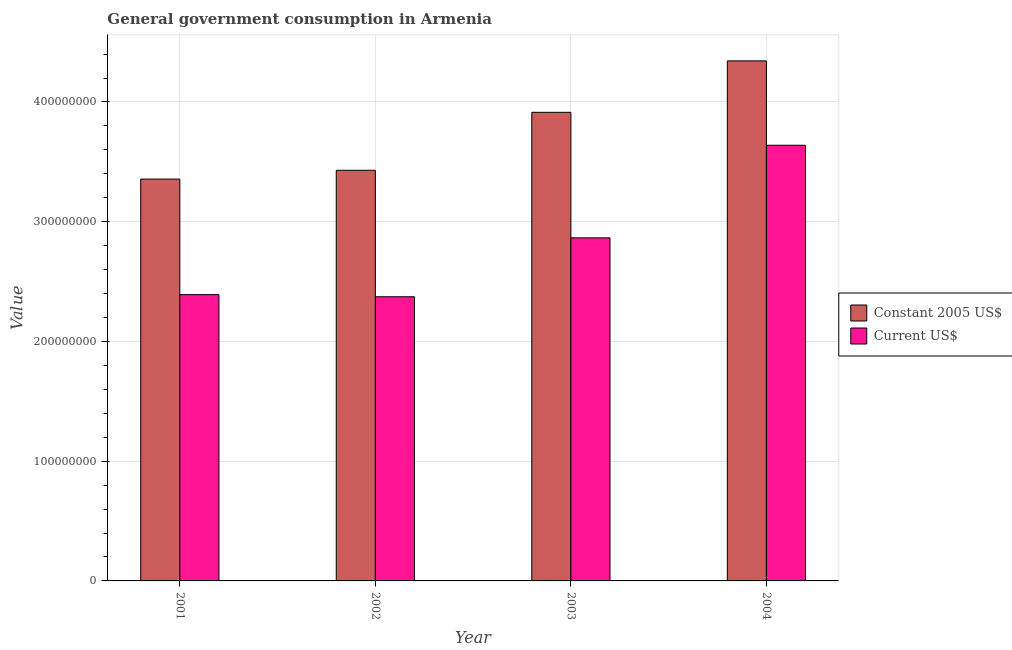How many groups of bars are there?
Give a very brief answer. 4. Are the number of bars per tick equal to the number of legend labels?
Ensure brevity in your answer.  Yes. What is the label of the 4th group of bars from the left?
Your answer should be very brief. 2004. What is the value consumed in current us$ in 2004?
Provide a short and direct response. 3.64e+08. Across all years, what is the maximum value consumed in constant 2005 us$?
Your answer should be compact. 4.34e+08. Across all years, what is the minimum value consumed in constant 2005 us$?
Offer a very short reply. 3.36e+08. In which year was the value consumed in constant 2005 us$ maximum?
Your answer should be compact. 2004. In which year was the value consumed in constant 2005 us$ minimum?
Offer a very short reply. 2001. What is the total value consumed in constant 2005 us$ in the graph?
Ensure brevity in your answer.  1.50e+09. What is the difference between the value consumed in current us$ in 2002 and that in 2004?
Offer a terse response. -1.27e+08. What is the difference between the value consumed in current us$ in 2001 and the value consumed in constant 2005 us$ in 2004?
Provide a short and direct response. -1.25e+08. What is the average value consumed in constant 2005 us$ per year?
Provide a short and direct response. 3.76e+08. In the year 2003, what is the difference between the value consumed in current us$ and value consumed in constant 2005 us$?
Keep it short and to the point. 0. What is the ratio of the value consumed in current us$ in 2001 to that in 2004?
Offer a terse response. 0.66. Is the difference between the value consumed in constant 2005 us$ in 2002 and 2003 greater than the difference between the value consumed in current us$ in 2002 and 2003?
Offer a very short reply. No. What is the difference between the highest and the second highest value consumed in current us$?
Ensure brevity in your answer.  7.73e+07. What is the difference between the highest and the lowest value consumed in current us$?
Provide a succinct answer. 1.27e+08. Is the sum of the value consumed in constant 2005 us$ in 2001 and 2003 greater than the maximum value consumed in current us$ across all years?
Your response must be concise. Yes. What does the 2nd bar from the left in 2004 represents?
Offer a terse response. Current US$. What does the 1st bar from the right in 2002 represents?
Provide a succinct answer. Current US$. How many years are there in the graph?
Your answer should be compact. 4. What is the difference between two consecutive major ticks on the Y-axis?
Give a very brief answer. 1.00e+08. Where does the legend appear in the graph?
Your response must be concise. Center right. How many legend labels are there?
Offer a very short reply. 2. How are the legend labels stacked?
Ensure brevity in your answer.  Vertical. What is the title of the graph?
Your answer should be compact. General government consumption in Armenia. What is the label or title of the X-axis?
Your response must be concise. Year. What is the label or title of the Y-axis?
Provide a succinct answer. Value. What is the Value of Constant 2005 US$ in 2001?
Make the answer very short. 3.36e+08. What is the Value in Current US$ in 2001?
Your response must be concise. 2.39e+08. What is the Value of Constant 2005 US$ in 2002?
Make the answer very short. 3.43e+08. What is the Value in Current US$ in 2002?
Keep it short and to the point. 2.37e+08. What is the Value of Constant 2005 US$ in 2003?
Offer a terse response. 3.91e+08. What is the Value of Current US$ in 2003?
Make the answer very short. 2.87e+08. What is the Value of Constant 2005 US$ in 2004?
Your response must be concise. 4.34e+08. What is the Value of Current US$ in 2004?
Your answer should be very brief. 3.64e+08. Across all years, what is the maximum Value of Constant 2005 US$?
Give a very brief answer. 4.34e+08. Across all years, what is the maximum Value in Current US$?
Provide a succinct answer. 3.64e+08. Across all years, what is the minimum Value in Constant 2005 US$?
Provide a short and direct response. 3.36e+08. Across all years, what is the minimum Value of Current US$?
Offer a terse response. 2.37e+08. What is the total Value of Constant 2005 US$ in the graph?
Keep it short and to the point. 1.50e+09. What is the total Value in Current US$ in the graph?
Your answer should be very brief. 1.13e+09. What is the difference between the Value of Constant 2005 US$ in 2001 and that in 2002?
Ensure brevity in your answer.  -7.34e+06. What is the difference between the Value in Current US$ in 2001 and that in 2002?
Your response must be concise. 1.76e+06. What is the difference between the Value in Constant 2005 US$ in 2001 and that in 2003?
Make the answer very short. -5.57e+07. What is the difference between the Value in Current US$ in 2001 and that in 2003?
Keep it short and to the point. -4.74e+07. What is the difference between the Value of Constant 2005 US$ in 2001 and that in 2004?
Your answer should be compact. -9.87e+07. What is the difference between the Value of Current US$ in 2001 and that in 2004?
Provide a succinct answer. -1.25e+08. What is the difference between the Value of Constant 2005 US$ in 2002 and that in 2003?
Provide a succinct answer. -4.84e+07. What is the difference between the Value of Current US$ in 2002 and that in 2003?
Ensure brevity in your answer.  -4.92e+07. What is the difference between the Value of Constant 2005 US$ in 2002 and that in 2004?
Ensure brevity in your answer.  -9.14e+07. What is the difference between the Value in Current US$ in 2002 and that in 2004?
Offer a very short reply. -1.27e+08. What is the difference between the Value in Constant 2005 US$ in 2003 and that in 2004?
Your answer should be very brief. -4.30e+07. What is the difference between the Value in Current US$ in 2003 and that in 2004?
Make the answer very short. -7.73e+07. What is the difference between the Value of Constant 2005 US$ in 2001 and the Value of Current US$ in 2002?
Your answer should be compact. 9.83e+07. What is the difference between the Value in Constant 2005 US$ in 2001 and the Value in Current US$ in 2003?
Offer a terse response. 4.91e+07. What is the difference between the Value in Constant 2005 US$ in 2001 and the Value in Current US$ in 2004?
Provide a succinct answer. -2.82e+07. What is the difference between the Value in Constant 2005 US$ in 2002 and the Value in Current US$ in 2003?
Ensure brevity in your answer.  5.64e+07. What is the difference between the Value in Constant 2005 US$ in 2002 and the Value in Current US$ in 2004?
Give a very brief answer. -2.09e+07. What is the difference between the Value of Constant 2005 US$ in 2003 and the Value of Current US$ in 2004?
Keep it short and to the point. 2.75e+07. What is the average Value in Constant 2005 US$ per year?
Your response must be concise. 3.76e+08. What is the average Value of Current US$ per year?
Your response must be concise. 2.82e+08. In the year 2001, what is the difference between the Value of Constant 2005 US$ and Value of Current US$?
Offer a very short reply. 9.65e+07. In the year 2002, what is the difference between the Value in Constant 2005 US$ and Value in Current US$?
Give a very brief answer. 1.06e+08. In the year 2003, what is the difference between the Value in Constant 2005 US$ and Value in Current US$?
Your answer should be compact. 1.05e+08. In the year 2004, what is the difference between the Value of Constant 2005 US$ and Value of Current US$?
Ensure brevity in your answer.  7.05e+07. What is the ratio of the Value in Constant 2005 US$ in 2001 to that in 2002?
Give a very brief answer. 0.98. What is the ratio of the Value of Current US$ in 2001 to that in 2002?
Offer a very short reply. 1.01. What is the ratio of the Value of Constant 2005 US$ in 2001 to that in 2003?
Keep it short and to the point. 0.86. What is the ratio of the Value of Current US$ in 2001 to that in 2003?
Provide a succinct answer. 0.83. What is the ratio of the Value in Constant 2005 US$ in 2001 to that in 2004?
Offer a very short reply. 0.77. What is the ratio of the Value of Current US$ in 2001 to that in 2004?
Provide a short and direct response. 0.66. What is the ratio of the Value in Constant 2005 US$ in 2002 to that in 2003?
Keep it short and to the point. 0.88. What is the ratio of the Value in Current US$ in 2002 to that in 2003?
Your response must be concise. 0.83. What is the ratio of the Value in Constant 2005 US$ in 2002 to that in 2004?
Provide a short and direct response. 0.79. What is the ratio of the Value of Current US$ in 2002 to that in 2004?
Give a very brief answer. 0.65. What is the ratio of the Value of Constant 2005 US$ in 2003 to that in 2004?
Provide a short and direct response. 0.9. What is the ratio of the Value of Current US$ in 2003 to that in 2004?
Provide a succinct answer. 0.79. What is the difference between the highest and the second highest Value in Constant 2005 US$?
Your answer should be very brief. 4.30e+07. What is the difference between the highest and the second highest Value in Current US$?
Make the answer very short. 7.73e+07. What is the difference between the highest and the lowest Value of Constant 2005 US$?
Keep it short and to the point. 9.87e+07. What is the difference between the highest and the lowest Value of Current US$?
Your answer should be very brief. 1.27e+08. 